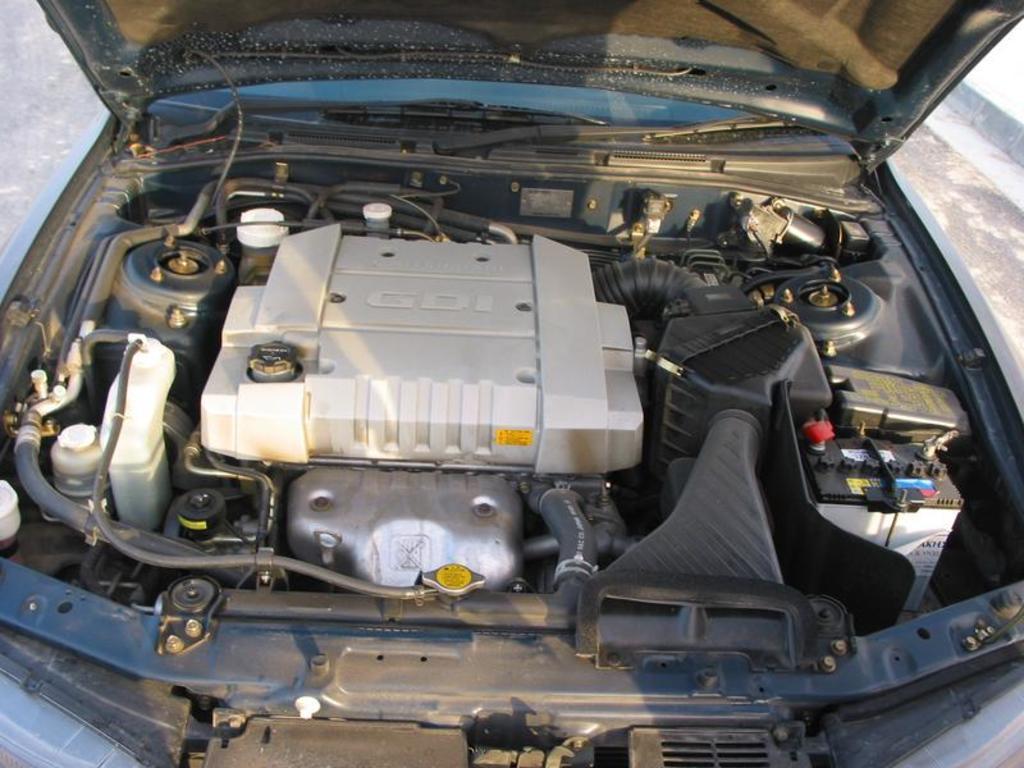In one or two sentences, can you explain what this image depicts? Here in this picture we can see front part of the car and the bonnet is open ended and we can see engine, battery and all other items present over there. 